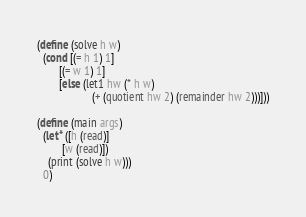<code> <loc_0><loc_0><loc_500><loc_500><_Scheme_>(define (solve h w)
  (cond [(= h 1) 1]
        [(= w 1) 1]
        [else (let1 hw (* h w)
                    (+ (quotient hw 2) (remainder hw 2)))]))

(define (main args)
  (let* ([h (read)]
         [w (read)])
    (print (solve h w)))
  0)
</code> 